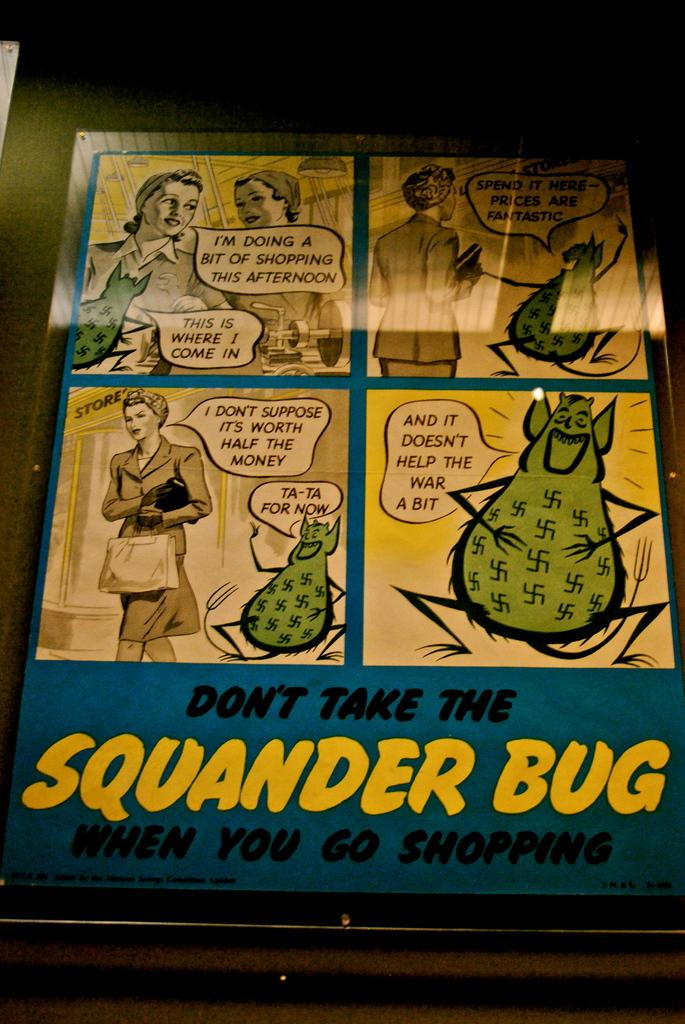Provide a one-sentence caption for the provided image. a poster for Don't take the Squander Bug when you go shopping. 